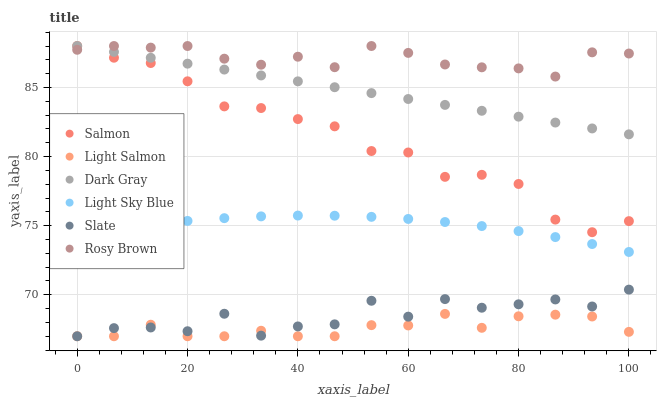Does Light Salmon have the minimum area under the curve?
Answer yes or no. Yes. Does Rosy Brown have the maximum area under the curve?
Answer yes or no. Yes. Does Slate have the minimum area under the curve?
Answer yes or no. No. Does Slate have the maximum area under the curve?
Answer yes or no. No. Is Dark Gray the smoothest?
Answer yes or no. Yes. Is Slate the roughest?
Answer yes or no. Yes. Is Rosy Brown the smoothest?
Answer yes or no. No. Is Rosy Brown the roughest?
Answer yes or no. No. Does Light Salmon have the lowest value?
Answer yes or no. Yes. Does Rosy Brown have the lowest value?
Answer yes or no. No. Does Dark Gray have the highest value?
Answer yes or no. Yes. Does Slate have the highest value?
Answer yes or no. No. Is Light Salmon less than Dark Gray?
Answer yes or no. Yes. Is Rosy Brown greater than Light Salmon?
Answer yes or no. Yes. Does Salmon intersect Rosy Brown?
Answer yes or no. Yes. Is Salmon less than Rosy Brown?
Answer yes or no. No. Is Salmon greater than Rosy Brown?
Answer yes or no. No. Does Light Salmon intersect Dark Gray?
Answer yes or no. No. 